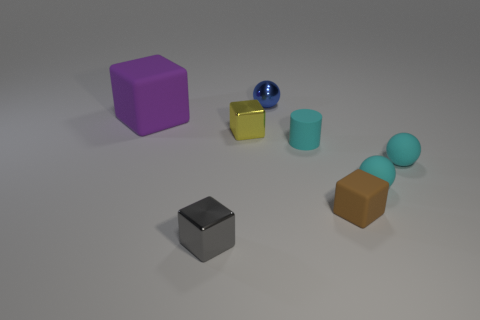Subtract all purple blocks. How many blocks are left? 3 Subtract 1 blocks. How many blocks are left? 3 Subtract all purple cubes. How many cubes are left? 3 Subtract all red blocks. Subtract all purple balls. How many blocks are left? 4 Add 1 purple things. How many objects exist? 9 Subtract all cylinders. How many objects are left? 7 Add 5 small metallic things. How many small metallic things are left? 8 Add 7 purple matte cubes. How many purple matte cubes exist? 8 Subtract 1 gray blocks. How many objects are left? 7 Subtract all large green shiny objects. Subtract all yellow shiny things. How many objects are left? 7 